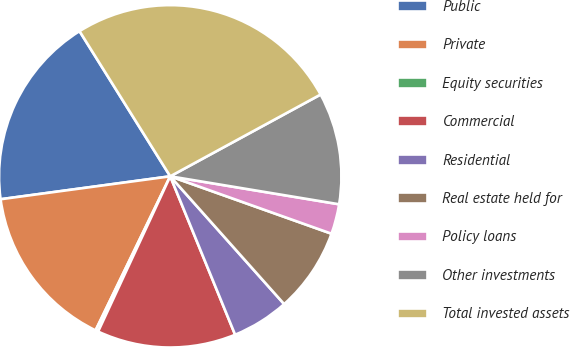Convert chart. <chart><loc_0><loc_0><loc_500><loc_500><pie_chart><fcel>Public<fcel>Private<fcel>Equity securities<fcel>Commercial<fcel>Residential<fcel>Real estate held for<fcel>Policy loans<fcel>Other investments<fcel>Total invested assets<nl><fcel>18.25%<fcel>15.68%<fcel>0.26%<fcel>13.11%<fcel>5.4%<fcel>7.97%<fcel>2.83%<fcel>10.54%<fcel>25.96%<nl></chart> 